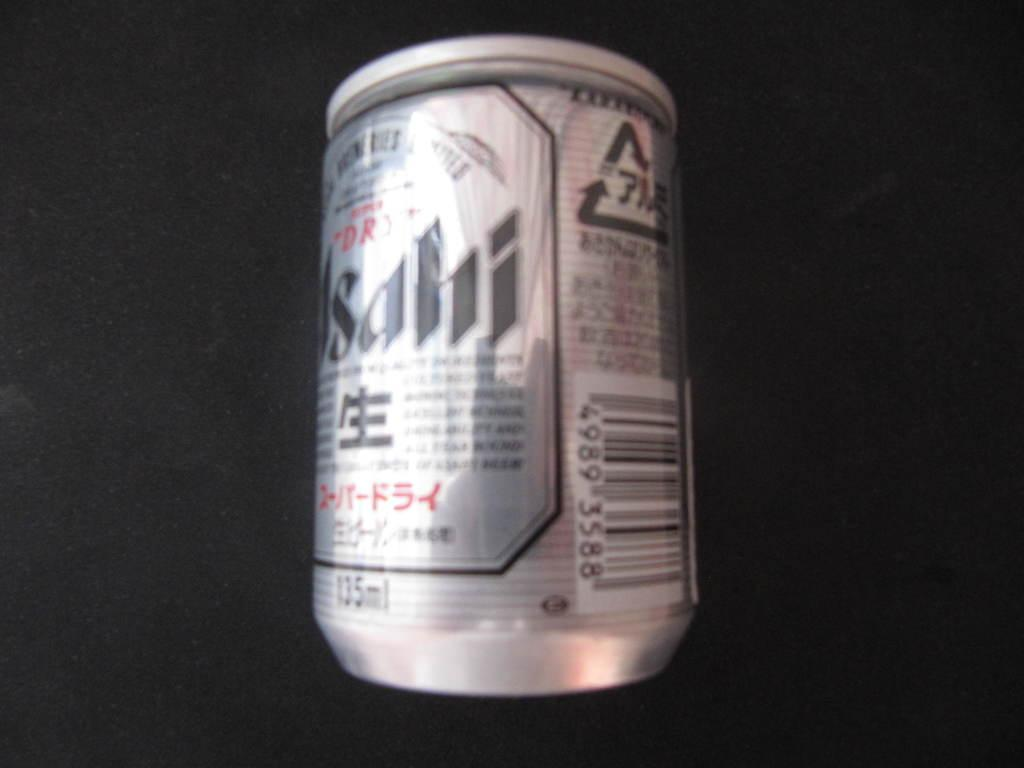What object is present in the image? There is a tin in the image. What is the color of the surface the tin is on? The tin is on a black surface. How many boys are playing with a bike in the image? There are no boys or bikes present in the image; it only features a tin on a black surface. 